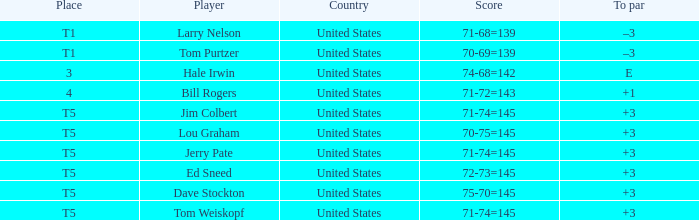Write the full table. {'header': ['Place', 'Player', 'Country', 'Score', 'To par'], 'rows': [['T1', 'Larry Nelson', 'United States', '71-68=139', '–3'], ['T1', 'Tom Purtzer', 'United States', '70-69=139', '–3'], ['3', 'Hale Irwin', 'United States', '74-68=142', 'E'], ['4', 'Bill Rogers', 'United States', '71-72=143', '+1'], ['T5', 'Jim Colbert', 'United States', '71-74=145', '+3'], ['T5', 'Lou Graham', 'United States', '70-75=145', '+3'], ['T5', 'Jerry Pate', 'United States', '71-74=145', '+3'], ['T5', 'Ed Sneed', 'United States', '72-73=145', '+3'], ['T5', 'Dave Stockton', 'United States', '75-70=145', '+3'], ['T5', 'Tom Weiskopf', 'United States', '71-74=145', '+3']]} What is the to par of player tom weiskopf, who has a 71-74=145 score? 3.0. 